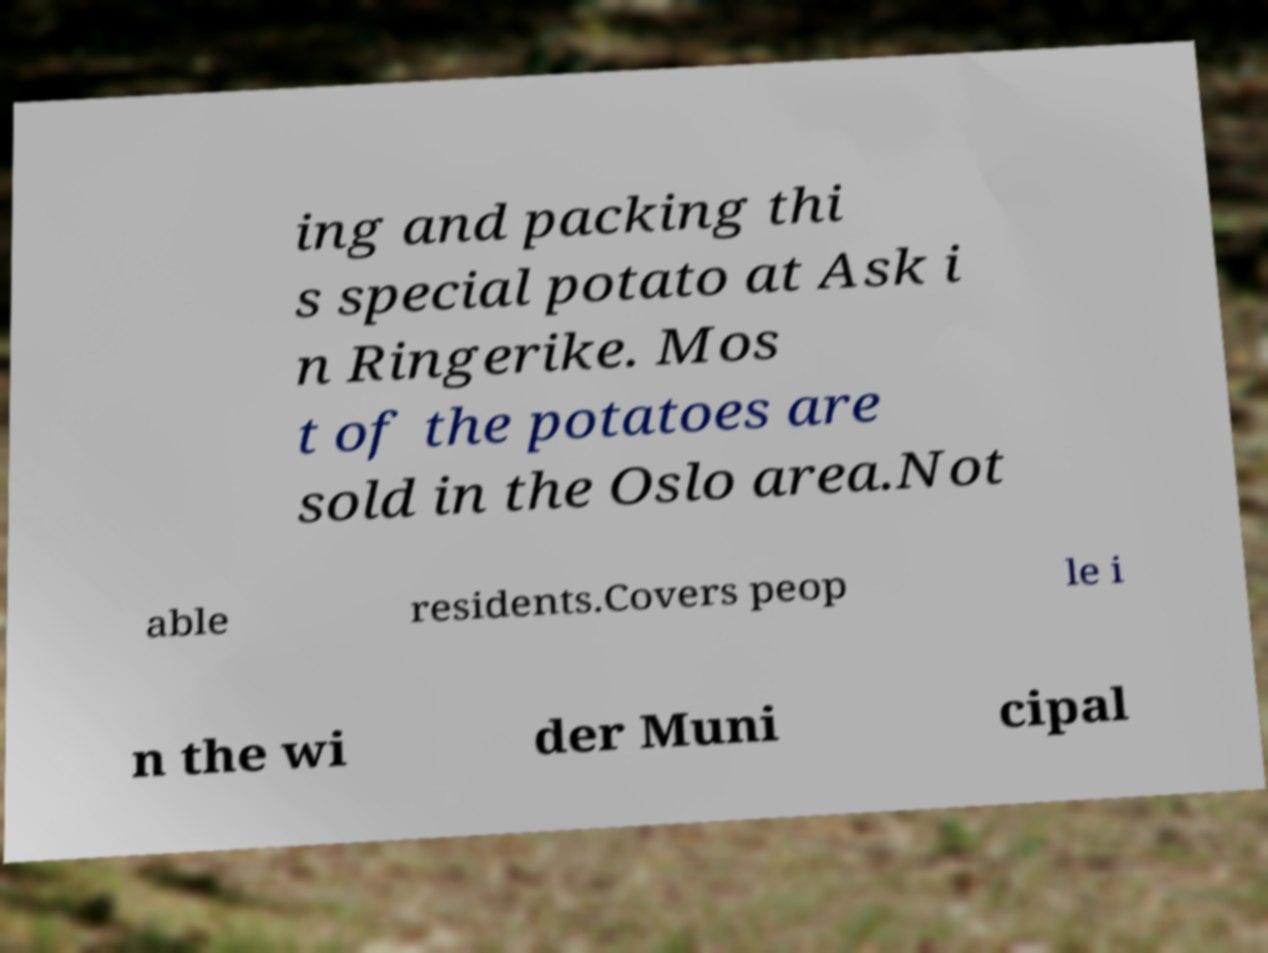I need the written content from this picture converted into text. Can you do that? ing and packing thi s special potato at Ask i n Ringerike. Mos t of the potatoes are sold in the Oslo area.Not able residents.Covers peop le i n the wi der Muni cipal 